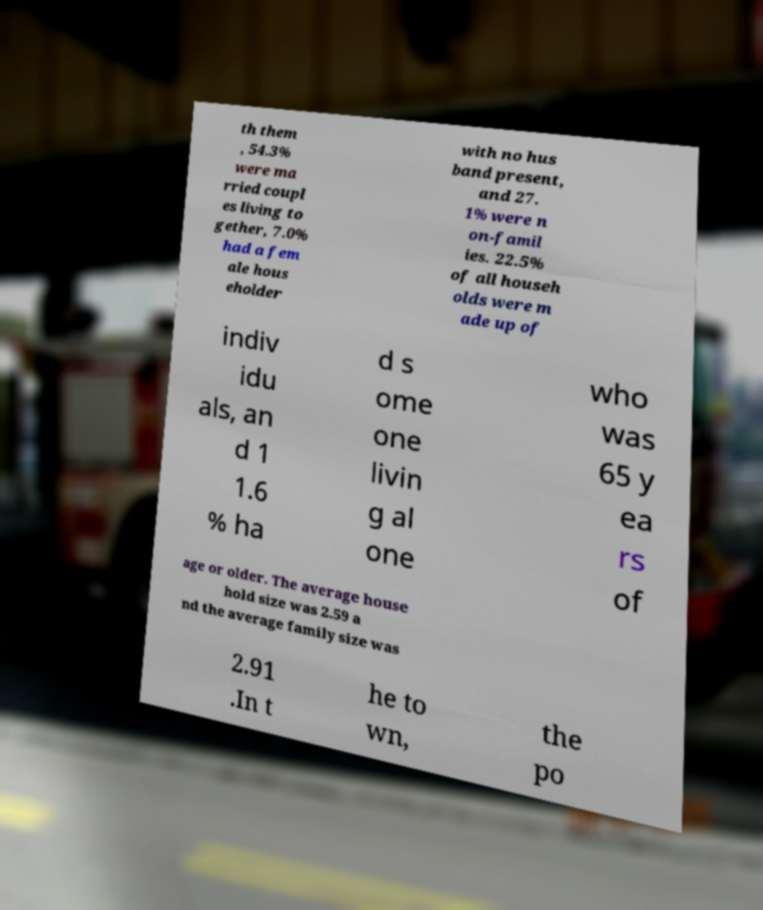Please identify and transcribe the text found in this image. th them , 54.3% were ma rried coupl es living to gether, 7.0% had a fem ale hous eholder with no hus band present, and 27. 1% were n on-famil ies. 22.5% of all househ olds were m ade up of indiv idu als, an d 1 1.6 % ha d s ome one livin g al one who was 65 y ea rs of age or older. The average house hold size was 2.59 a nd the average family size was 2.91 .In t he to wn, the po 